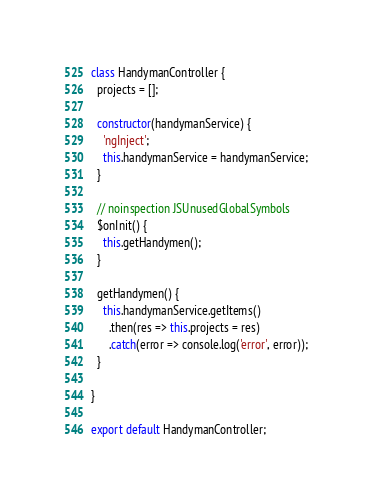<code> <loc_0><loc_0><loc_500><loc_500><_JavaScript_>class HandymanController {
  projects = [];

  constructor(handymanService) {
    'ngInject';
    this.handymanService = handymanService;
  }

  // noinspection JSUnusedGlobalSymbols
  $onInit() {
    this.getHandymen();
  }

  getHandymen() {
    this.handymanService.getItems()
      .then(res => this.projects = res)
      .catch(error => console.log('error', error));
  }

}

export default HandymanController;
</code> 